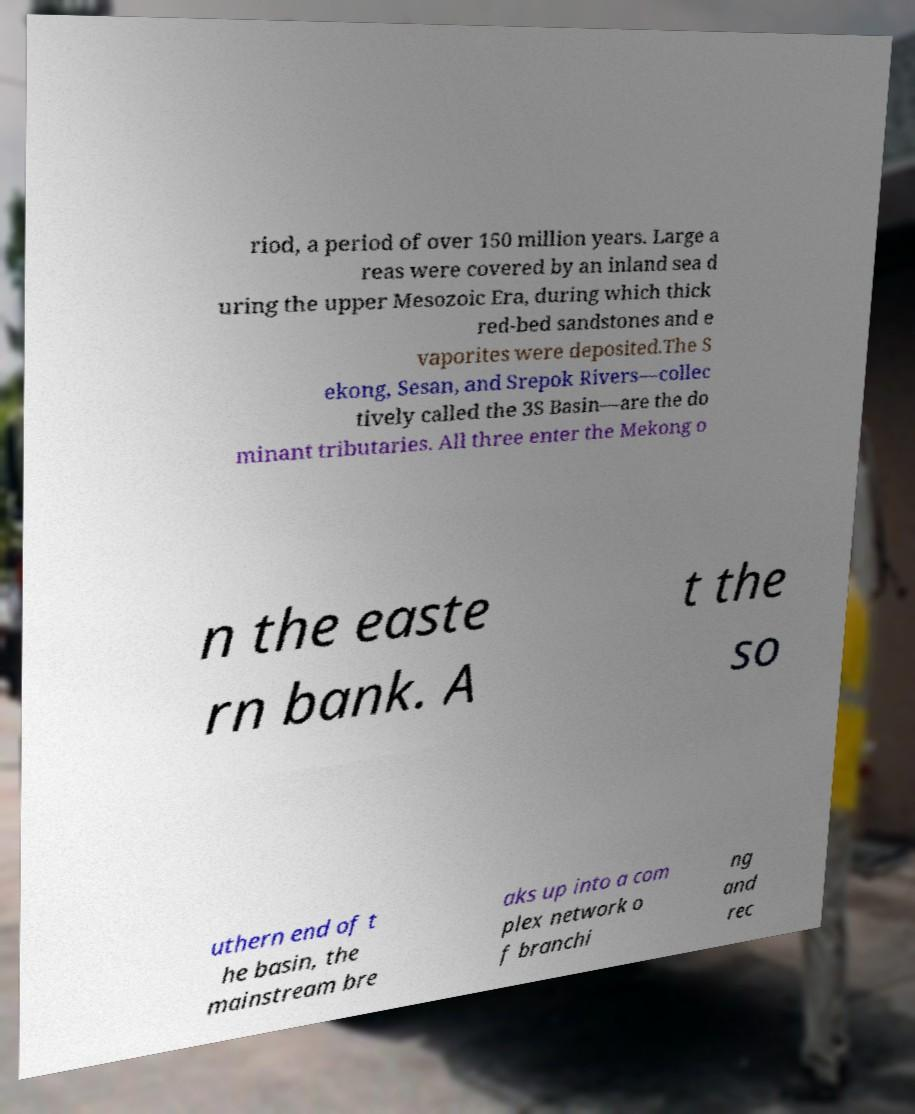For documentation purposes, I need the text within this image transcribed. Could you provide that? riod, a period of over 150 million years. Large a reas were covered by an inland sea d uring the upper Mesozoic Era, during which thick red-bed sandstones and e vaporites were deposited.The S ekong, Sesan, and Srepok Rivers—collec tively called the 3S Basin—are the do minant tributaries. All three enter the Mekong o n the easte rn bank. A t the so uthern end of t he basin, the mainstream bre aks up into a com plex network o f branchi ng and rec 